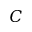<formula> <loc_0><loc_0><loc_500><loc_500>C</formula> 